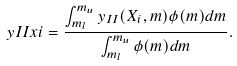<formula> <loc_0><loc_0><loc_500><loc_500>\ y I I x i = \frac { \int ^ { m _ { u } } _ { m _ { l } } y _ { I I } ( X _ { i } , m ) \phi ( m ) d m } { \int ^ { m _ { u } } _ { m _ { l } } \phi ( m ) d m } .</formula> 